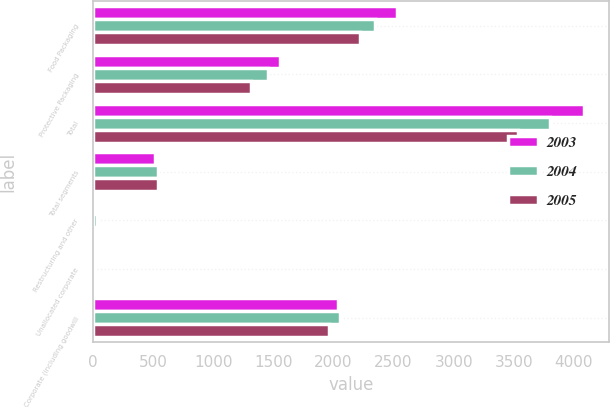<chart> <loc_0><loc_0><loc_500><loc_500><stacked_bar_chart><ecel><fcel>Food Packaging<fcel>Protective Packaging<fcel>Total<fcel>Total segments<fcel>Restructuring and other<fcel>Unallocated corporate<fcel>Corporate (including goodwill<nl><fcel>2003<fcel>2532.1<fcel>1553<fcel>4085.1<fcel>513.1<fcel>1.7<fcel>1<fcel>2041.2<nl><fcel>2004<fcel>2346.9<fcel>1451.2<fcel>3798.1<fcel>536.9<fcel>33<fcel>0.9<fcel>2050.7<nl><fcel>2005<fcel>2218.6<fcel>1313.3<fcel>3531.9<fcel>541<fcel>0.5<fcel>0.6<fcel>1960.8<nl></chart> 